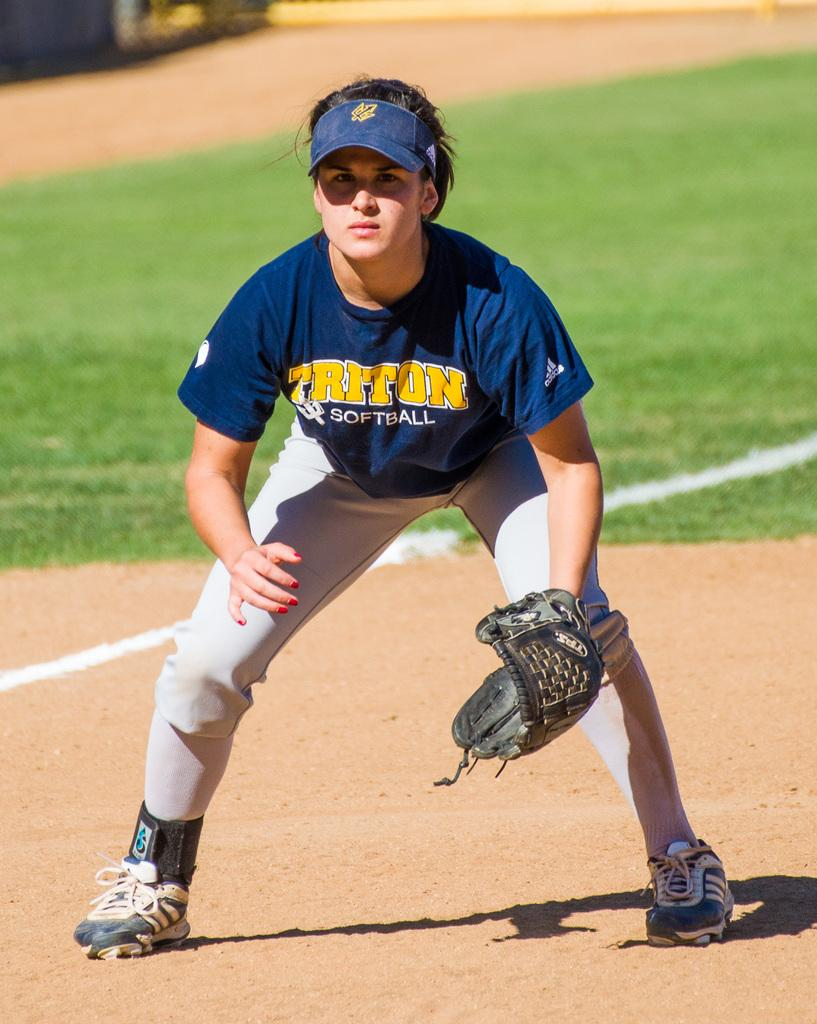What is the main subject of the image? There is a woman standing in the middle of the image. What is the woman doing in the image? The woman is watching something. What type of environment is visible in the image? There is grass visible behind the woman. What type of shoes is the visitor wearing in the image? There is no visitor present in the image, and therefore no shoes to describe. 